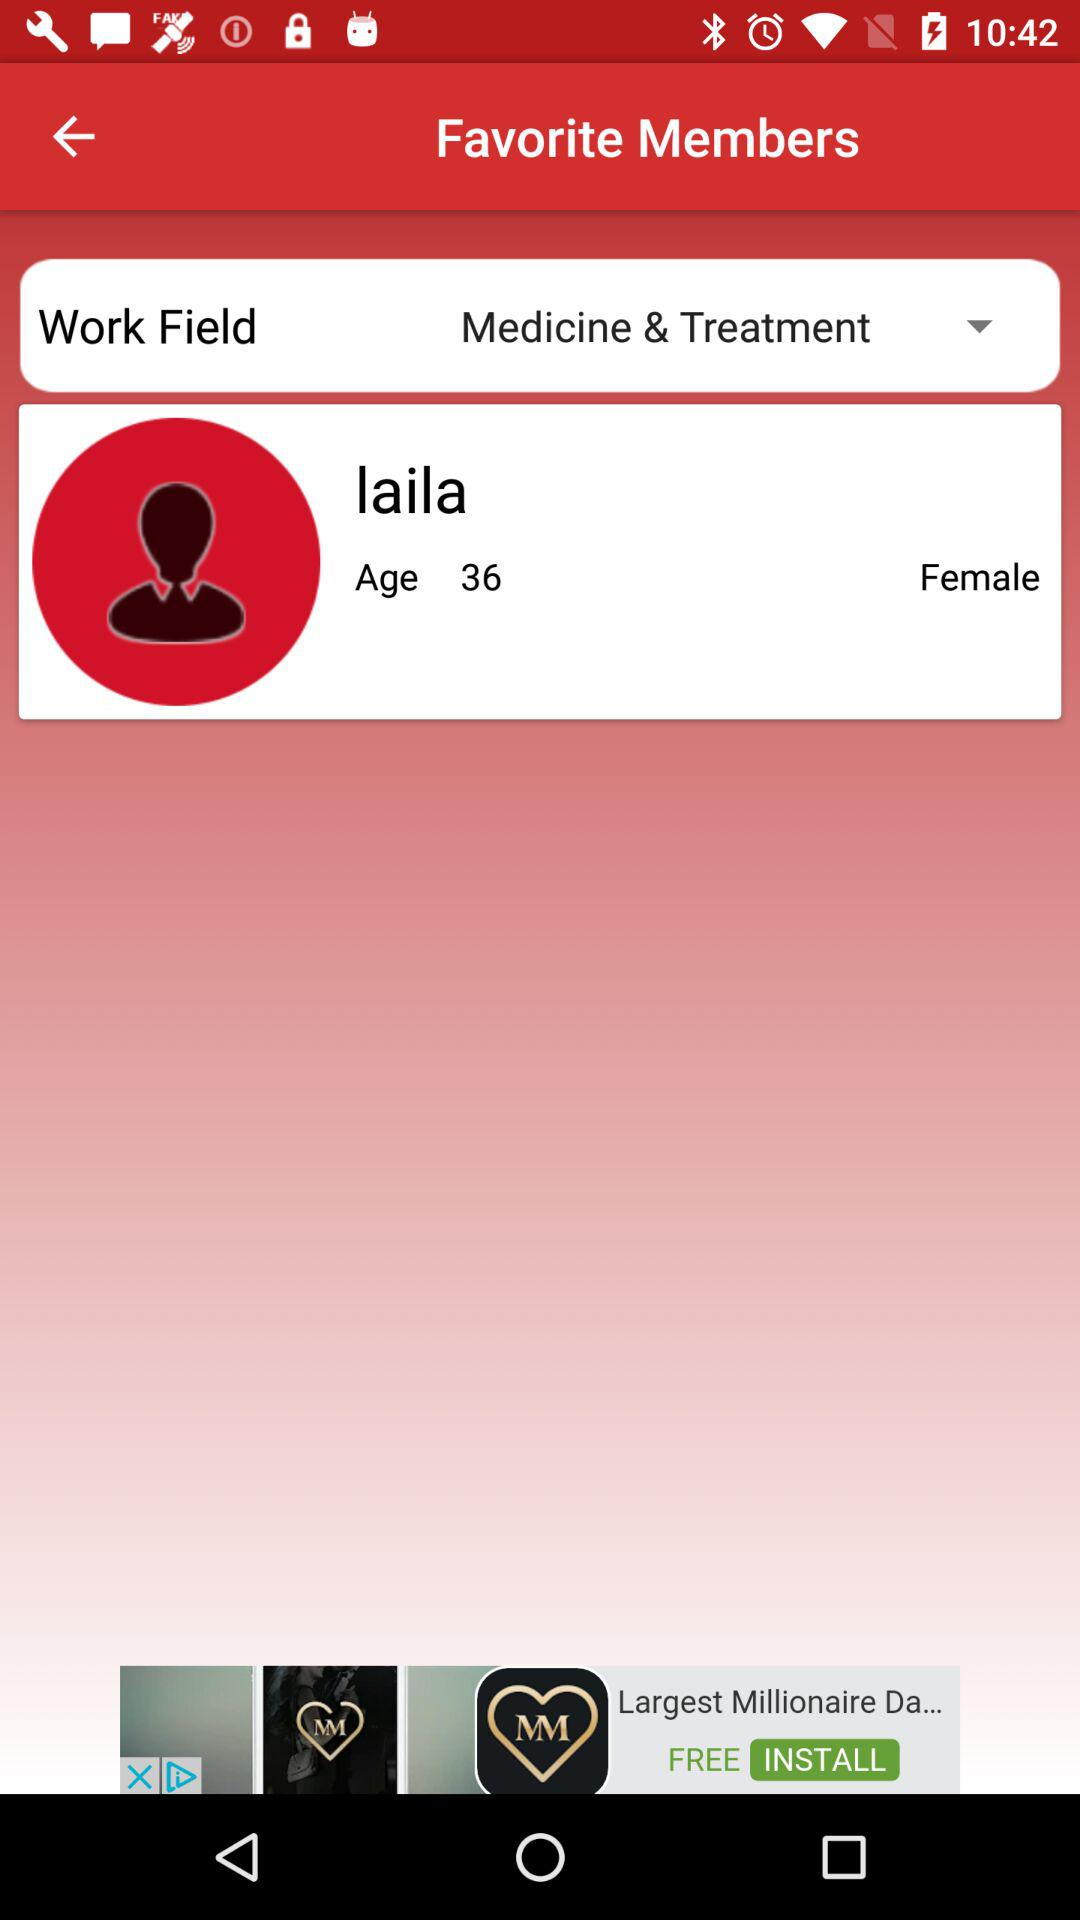How many years old is Laila?
Answer the question using a single word or phrase. 36 